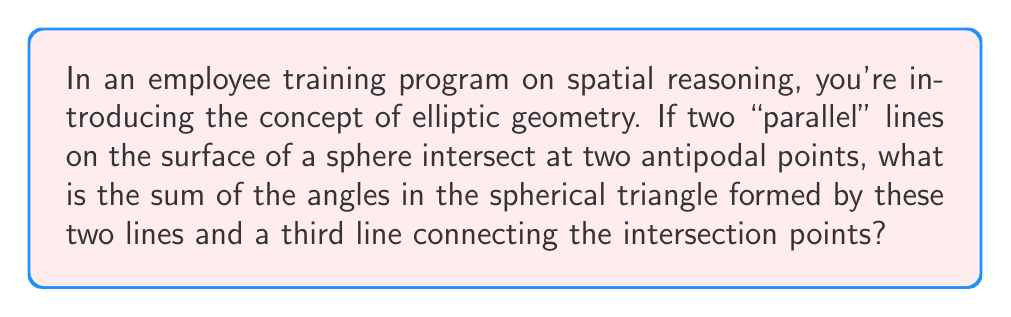Can you answer this question? Let's approach this step-by-step:

1) In elliptic geometry, specifically on the surface of a sphere, "parallel" lines are great circles that intersect at two antipodal points.

2) When we add a third line (another great circle) connecting these intersection points, we form a spherical triangle.

3) In spherical geometry, the sum of angles in a triangle is always greater than 180°. The formula for the sum of angles in a spherical triangle is:

   $$A + B + C = 180° + \frac{a}{R}$$

   Where $A$, $B$, and $C$ are the angles of the triangle, $a$ is the area of the triangle, and $R$ is the radius of the sphere.

4) In our case, we have two special properties:
   a) Two of the angles are right angles (90°) because the "parallel" lines intersect at right angles to the third line (due to the properties of great circles).
   b) The area of this triangle is one-eighth of the surface area of the sphere, as it's formed by three great circles dividing the sphere into eight equal parts.

5) The surface area of a sphere is $4\pi R^2$, so the area of our triangle is:

   $$a = \frac{1}{8} \cdot 4\pi R^2 = \frac{\pi R^2}{2}$$

6) Substituting this into our formula:

   $$90° + 90° + C = 180° + \frac{\pi R^2/2}{R} = 180° + \frac{\pi R}{2}$$

7) Simplifying:

   $$180° + C = 180° + 90° = 270°$$

8) Therefore, $C = 90°$

9) The sum of all angles is thus:

   $$90° + 90° + 90° = 270°$$
Answer: 270° 